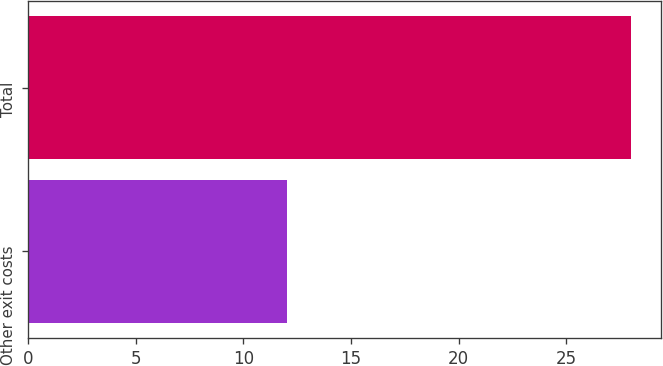<chart> <loc_0><loc_0><loc_500><loc_500><bar_chart><fcel>Other exit costs<fcel>Total<nl><fcel>12<fcel>28<nl></chart> 